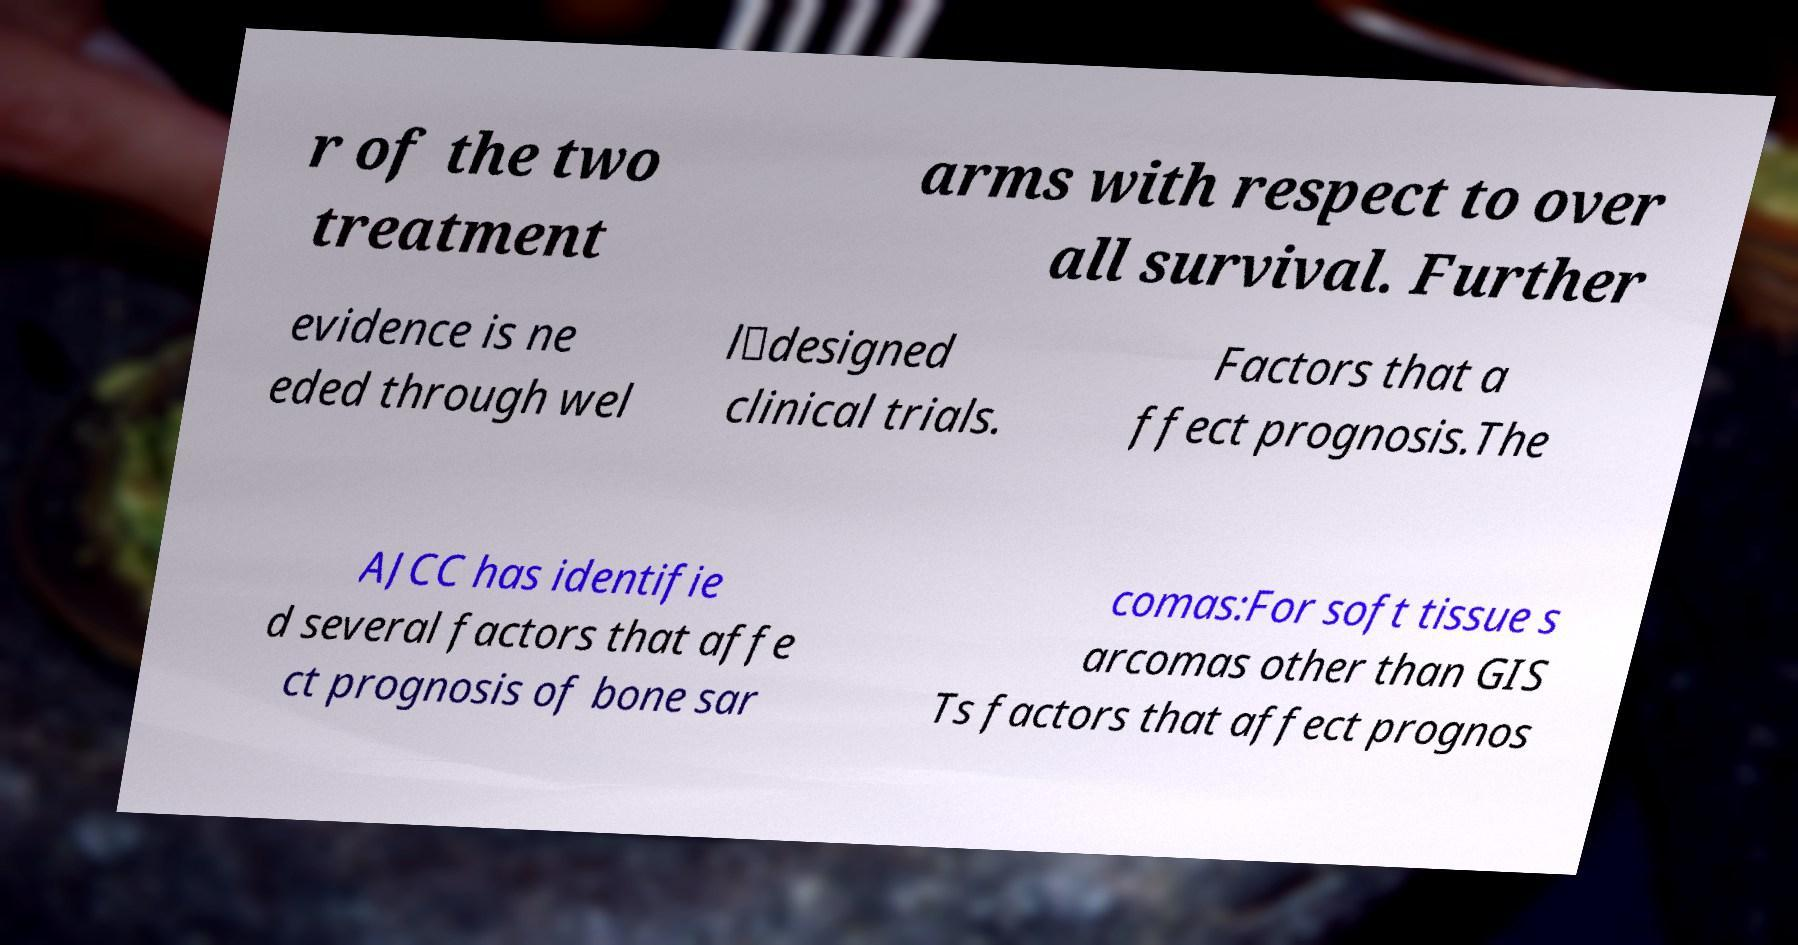What messages or text are displayed in this image? I need them in a readable, typed format. r of the two treatment arms with respect to over all survival. Further evidence is ne eded through wel l‐designed clinical trials. Factors that a ffect prognosis.The AJCC has identifie d several factors that affe ct prognosis of bone sar comas:For soft tissue s arcomas other than GIS Ts factors that affect prognos 